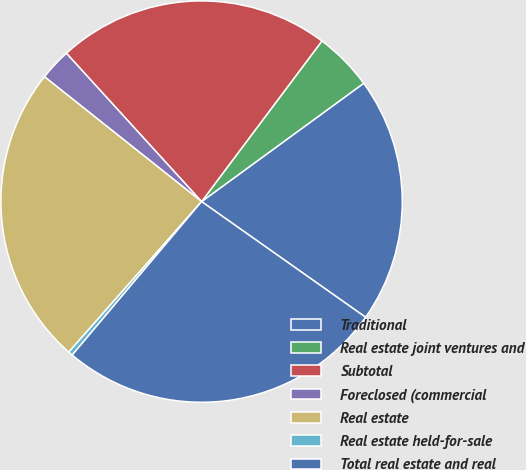Convert chart. <chart><loc_0><loc_0><loc_500><loc_500><pie_chart><fcel>Traditional<fcel>Real estate joint ventures and<fcel>Subtotal<fcel>Foreclosed (commercial<fcel>Real estate<fcel>Real estate held-for-sale<fcel>Total real estate and real<nl><fcel>19.81%<fcel>4.73%<fcel>22.0%<fcel>2.55%<fcel>24.18%<fcel>0.36%<fcel>26.37%<nl></chart> 